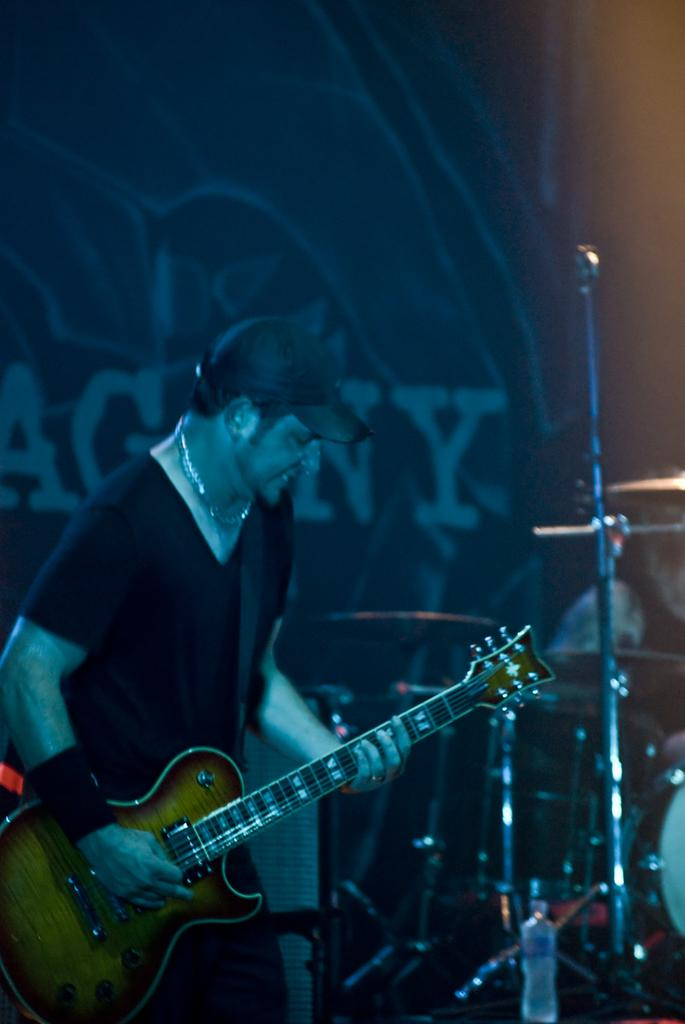Who is the main subject in the image? There is a man in the image. What is the man doing in the image? The man is playing a guitar. Can you describe the man's attire in the image? The man is wearing a cap. What other objects are related to the man's activity in the image? There are musical instruments in the image. How many passengers are visible in the image? There are no passengers present in the image; it features a man playing a guitar. What type of frame surrounds the image? The provided facts do not mention a frame surrounding the image. 